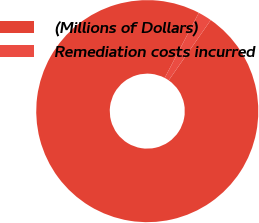Convert chart to OTSL. <chart><loc_0><loc_0><loc_500><loc_500><pie_chart><fcel>(Millions of Dollars)<fcel>Remediation costs incurred<nl><fcel>98.0%<fcel>2.0%<nl></chart> 